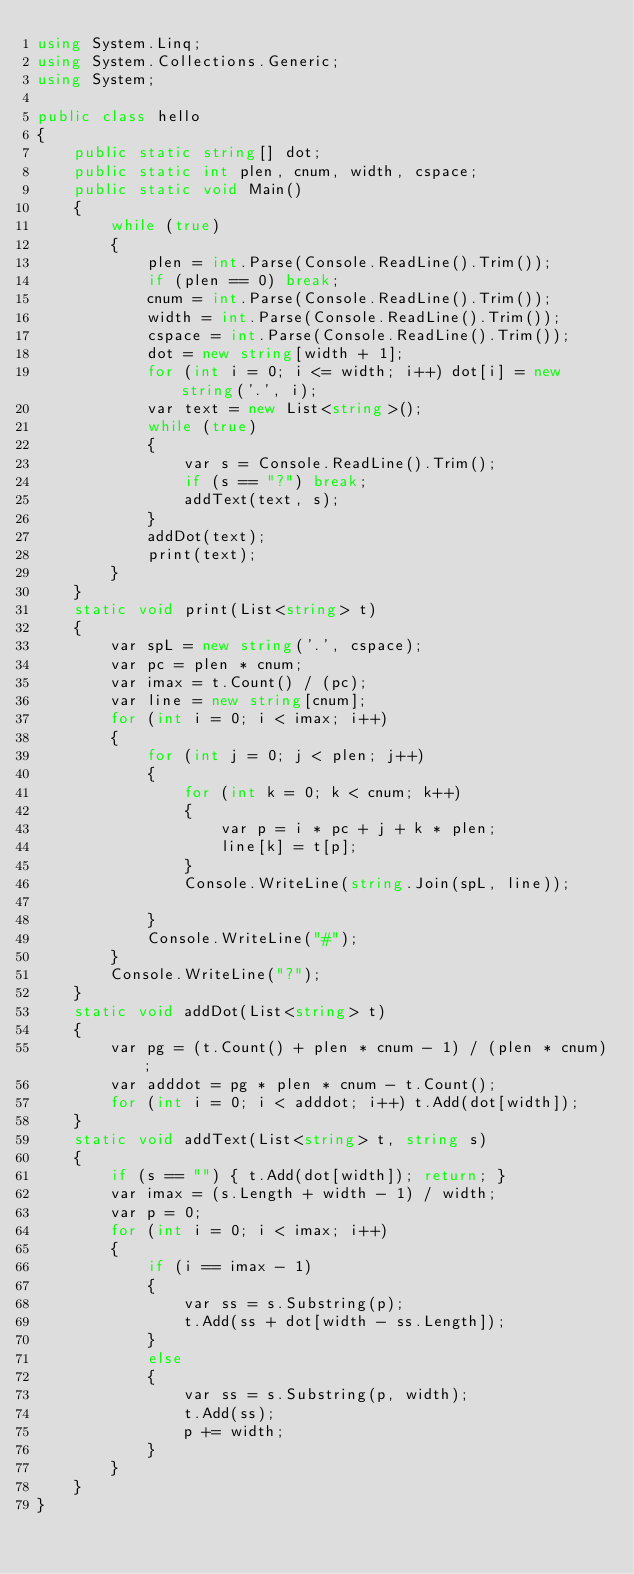Convert code to text. <code><loc_0><loc_0><loc_500><loc_500><_C#_>using System.Linq;
using System.Collections.Generic;
using System;

public class hello
{
    public static string[] dot;
    public static int plen, cnum, width, cspace;
    public static void Main()
    {
        while (true)
        {
            plen = int.Parse(Console.ReadLine().Trim());
            if (plen == 0) break;
            cnum = int.Parse(Console.ReadLine().Trim());
            width = int.Parse(Console.ReadLine().Trim());
            cspace = int.Parse(Console.ReadLine().Trim());
            dot = new string[width + 1];
            for (int i = 0; i <= width; i++) dot[i] = new string('.', i);
            var text = new List<string>();
            while (true)
            {
                var s = Console.ReadLine().Trim();
                if (s == "?") break;
                addText(text, s);
            }
            addDot(text);
            print(text);
        }
    }
    static void print(List<string> t)
    {
        var spL = new string('.', cspace);
        var pc = plen * cnum;
        var imax = t.Count() / (pc);
        var line = new string[cnum];
        for (int i = 0; i < imax; i++)
        {
            for (int j = 0; j < plen; j++)
            {
                for (int k = 0; k < cnum; k++)
                {
                    var p = i * pc + j + k * plen;
                    line[k] = t[p];
                }
                Console.WriteLine(string.Join(spL, line));

            }
            Console.WriteLine("#");
        }
        Console.WriteLine("?");
    }
    static void addDot(List<string> t)
    {
        var pg = (t.Count() + plen * cnum - 1) / (plen * cnum);
        var adddot = pg * plen * cnum - t.Count();
        for (int i = 0; i < adddot; i++) t.Add(dot[width]);
    }
    static void addText(List<string> t, string s)
    {
        if (s == "") { t.Add(dot[width]); return; }
        var imax = (s.Length + width - 1) / width;
        var p = 0;
        for (int i = 0; i < imax; i++)
        {
            if (i == imax - 1)
            {
                var ss = s.Substring(p);
                t.Add(ss + dot[width - ss.Length]);
            }
            else
            {
                var ss = s.Substring(p, width);
                t.Add(ss);
                p += width;
            }
        }
    }
}
</code> 